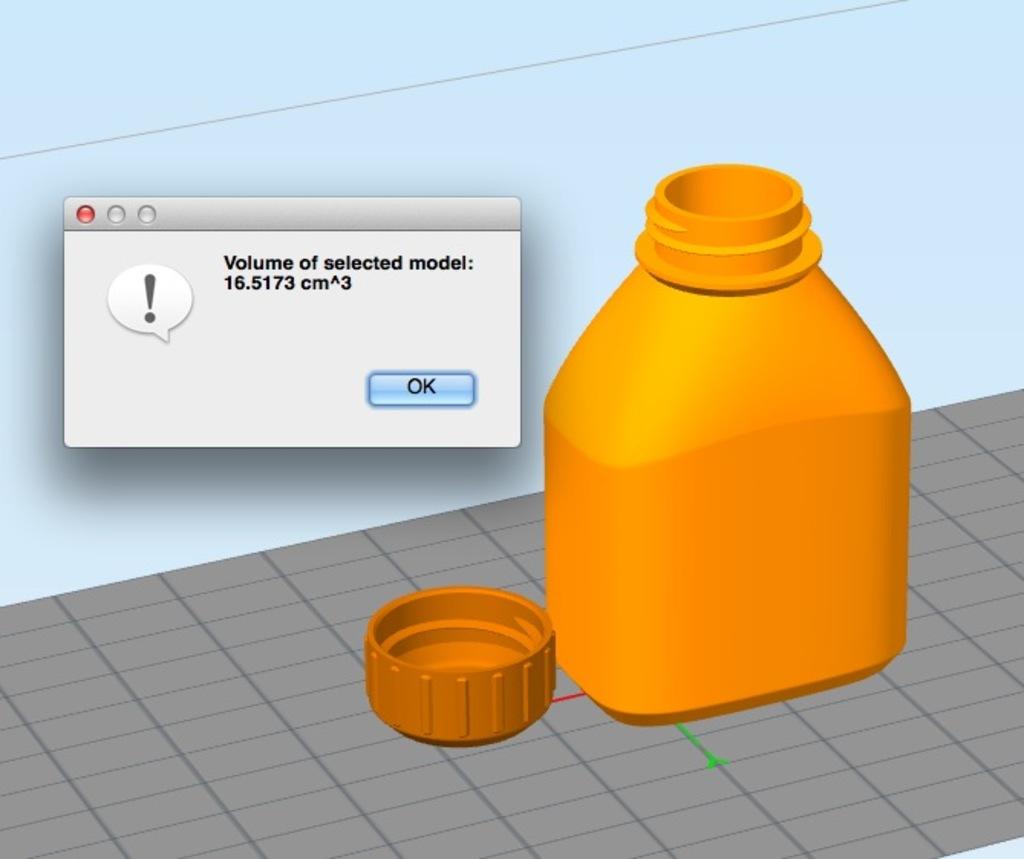Is there an "ok" button?
Provide a succinct answer. Yes. 